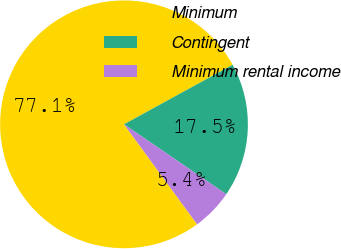Convert chart. <chart><loc_0><loc_0><loc_500><loc_500><pie_chart><fcel>Minimum<fcel>Contingent<fcel>Minimum rental income<nl><fcel>77.07%<fcel>17.52%<fcel>5.41%<nl></chart> 